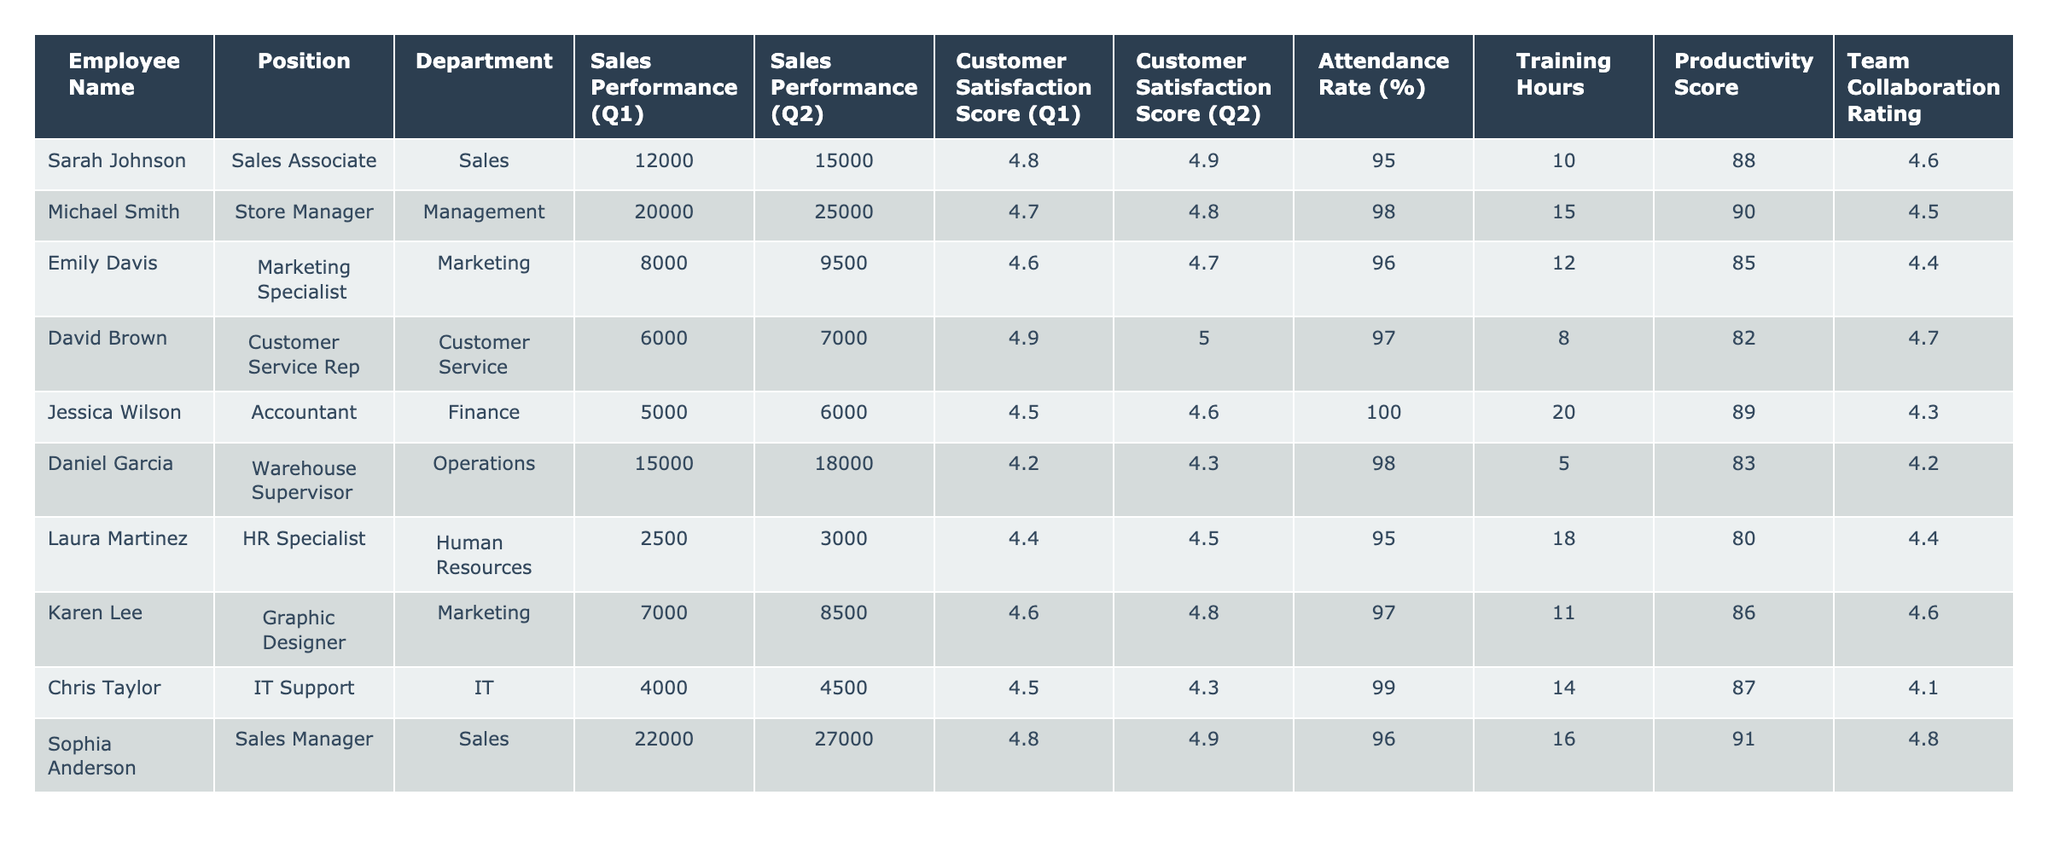What is the Sales Performance of Sarah Johnson in Q2? The table shows that Sarah Johnson's Sales Performance in Q2 is 15,000.
Answer: 15,000 What is the average Customer Satisfaction Score for all employees in Q1? To find the average, add all the Customer Satisfaction Scores for Q1 (4.8 + 4.7 + 4.6 + 4.9 + 4.5 + 4.2 + 4.4 + 4.6 + 4.5 + 4.8) = 46.6. There are 10 scores, so the average is 46.6 / 10 = 4.66.
Answer: 4.66 Who has the highest Attendance Rate? Looking at the table, Michael Smith has the highest Attendance Rate of 98%.
Answer: Michael Smith What was the difference in Sales Performance for Daniel Garcia from Q1 to Q2? The Sales Performance for Daniel Garcia in Q1 was 15,000 and in Q2 was 18,000. The difference is 18,000 - 15,000 = 3,000.
Answer: 3,000 Is David Brown's Customer Satisfaction Score higher in Q2 than in Q1? David Brown's Customer Satisfaction Score in Q1 is 4.9 and in Q2 is 5.0. Since 5.0 is greater than 4.9, it is true.
Answer: Yes What is the total Training Hours contributed by all employees in the Finance department? In the Finance department, only Jessica Wilson is listed with 20 Training Hours. Thus, the total is 20.
Answer: 20 Which employee has the lowest Productivity Score? The table lists Laura Martinez with the lowest Productivity Score of 80.
Answer: Laura Martinez What is the average Attendance Rate for employees in the Marketing department? In the Marketing department, Emily Davis has an Attendance Rate of 96% and Karen Lee has 97%. The average is (96 + 97) / 2 = 96.5%.
Answer: 96.5% Is the Team Collaboration Rating for Chris Taylor above average (4.5)? Chris Taylor's Team Collaboration Rating is 4.1, which is below the average of 4.5.
Answer: No Which employee shows the greatest improvement in Sales Performance from Q1 to Q2? Calculating the improvement for each employee: Sarah Johnson: 15,000 - 12,000 = 3,000; Michael Smith: 25,000 - 20,000 = 5,000; Emily Davis: 9,500 - 8,000 = 1,500; and so on, we find Michael Smith improved by 5,000, which is the greatest.
Answer: Michael Smith 